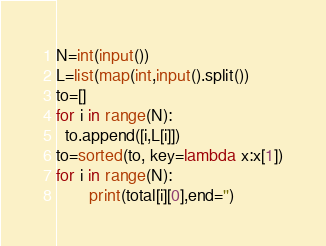<code> <loc_0><loc_0><loc_500><loc_500><_Python_>N=int(input())
L=list(map(int,input().split())
to=[]
for i in range(N):
  to.append([i,L[i]])
to=sorted(to, key=lambda x:x[1])
for i in range(N):
       print(total[i][0],end='')</code> 